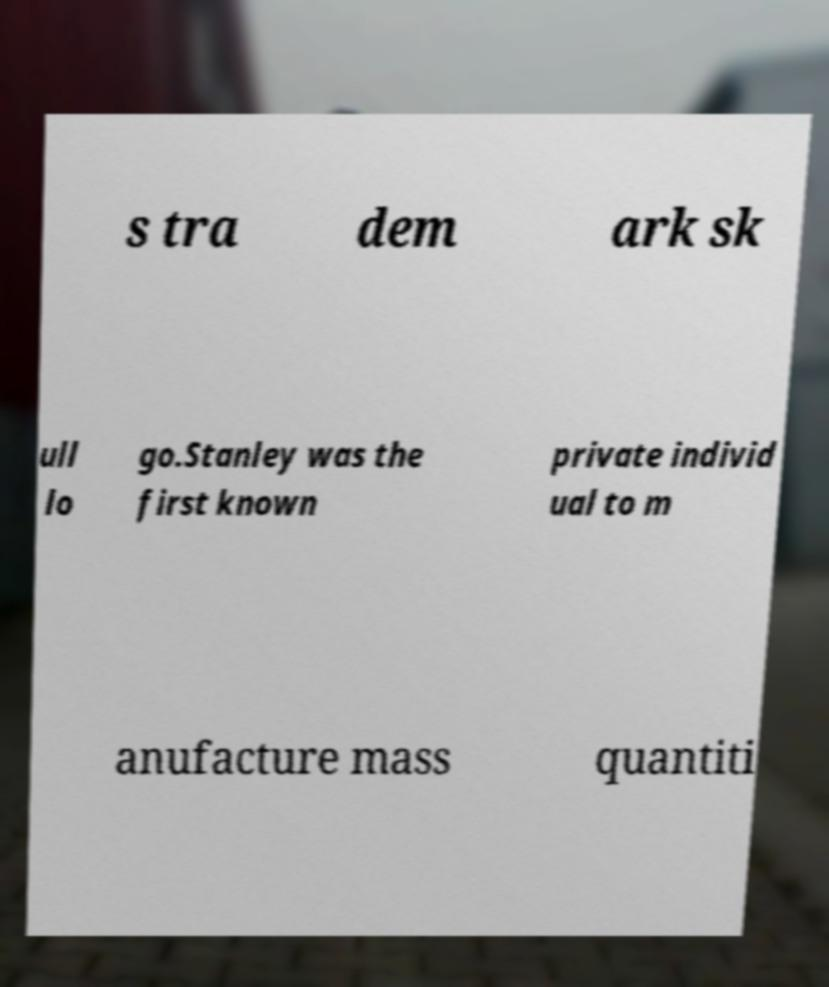Please identify and transcribe the text found in this image. s tra dem ark sk ull lo go.Stanley was the first known private individ ual to m anufacture mass quantiti 